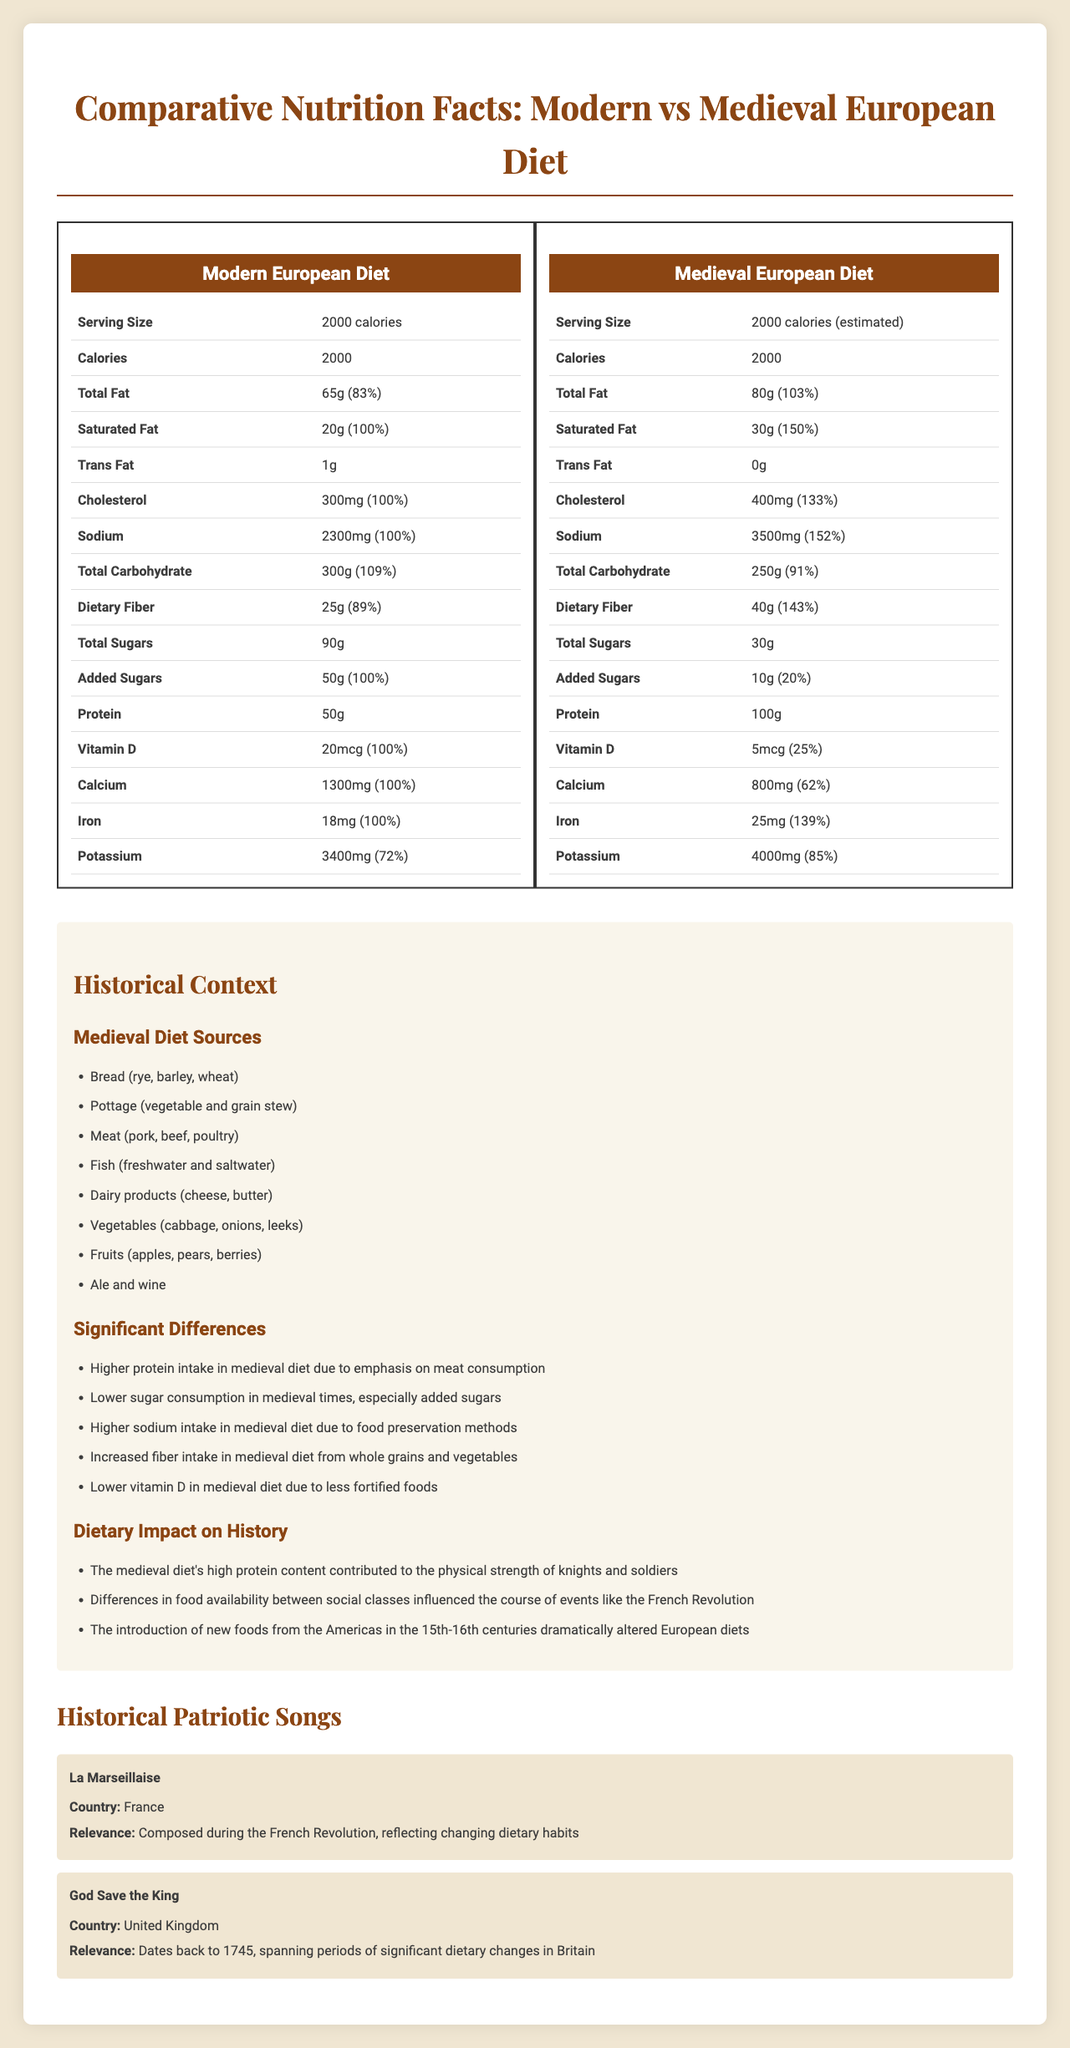what is the serving size of the modern European diet? The serving size for the modern European diet is specified as "2000 calories."
Answer: 2000 calories What is the cholesterol content in the medieval European diet? The cholesterol content in the medieval European diet is listed as 400mg.
Answer: 400mg How much vitamin D is in the modern European diet? The modern European diet has 20mcg of vitamin D.
Answer: 20mcg What is the total carbohydrate amount in the medieval European diet? The total carbohydrate amount in the medieval European diet is 250g.
Answer: 250g What is a significant difference between the modern and medieval European diets? The historical context section lists several significant differences, including higher protein intake in the medieval diet.
Answer: Higher protein intake in the medieval diet Which of the following is a source of the medieval diet? A. Pasta B. Bread C. Chocolate Bread is listed as one of the sources in the medieval diet content.
Answer: B Which diet has a higher total fat content? A. Modern European diet B. Medieval European diet The medieval European diet has a total fat content of 80g, whereas the modern European diet has 65g.
Answer: B What percentage of the daily value (%DV) of sodium does the medieval European diet have? The sodium content in the medieval European diet is 3500mg, which is 152% of the daily value.
Answer: 152% Is the total fiber amount in the medieval European diet higher than in the modern European diet? The medieval diet contains 40g of fiber compared to 25g in the modern diet.
Answer: Yes Summarize the main idea of the document. The document provides a comparative analysis of the modern and medieval European diets, detailing the nutritional facts for each, pointing out significant differences, and discussing the historical impact of these dietary habits. It concludes by relating the dietary context to historical patriotic songs and their relevance.
Answer: This document compares the nutritional facts of modern and medieval European diets, highlighting differences in fat, protein, sugar, and other contents while also providing historical context and the impact of dietary habits on history. What were the typical drinks included in the medieval diet? The document lists "Ale and wine" but does not provide specific details on typical quantities consumed.
Answer: Cannot be determined How does the medieval diet's saturated fat content compare to the modern diet? The medieval diet's saturated fat content is 30g (150% daily value) compared to the modern diet's 20g (100% daily value).
Answer: The medieval diet has higher saturated fat content 